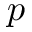Convert formula to latex. <formula><loc_0><loc_0><loc_500><loc_500>p</formula> 